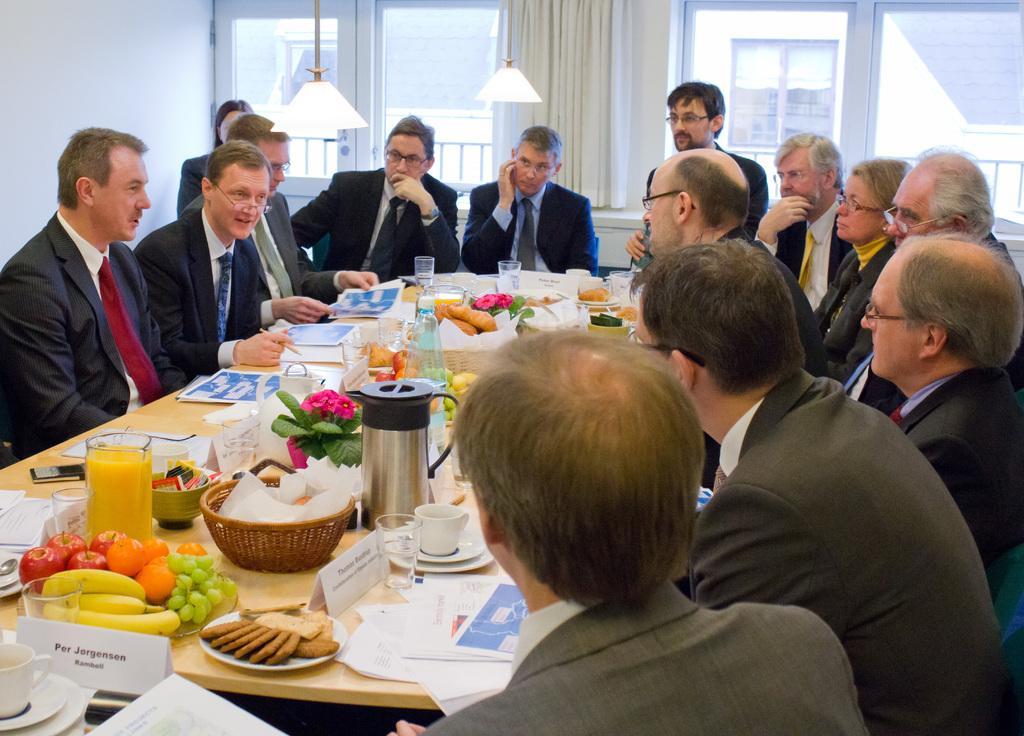How would you summarize this image in a sentence or two? In this image there are a few people sitting on their chairs, in front of them there is a table with so many food items, juice, glasses, plates, cups, spoons, fruits, flask, papers, flower vase and other objects placed on top of it. In the background there is a wall and windows with curtains, through the glass window we can see there is a building and there are two lamps hanging from the ceiling. 